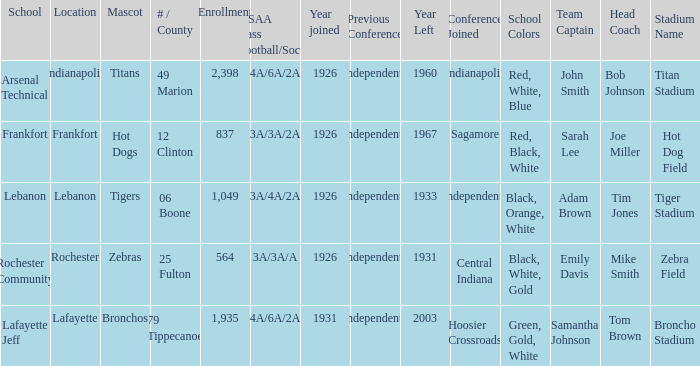What is the lowest enrollment that has Lafayette as the location? 1935.0. 